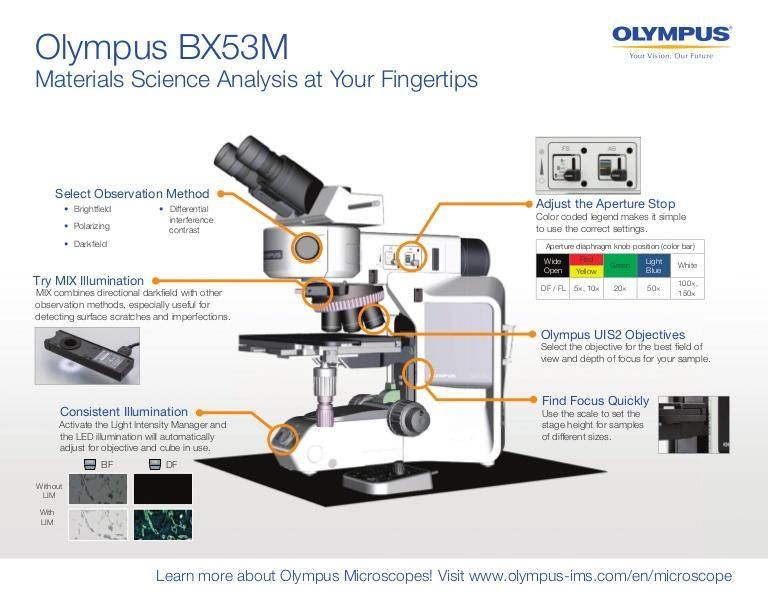Which are types of lighting in Olympus BX53M microscope?
Answer the question with a short phrase. MIX, Consistent 